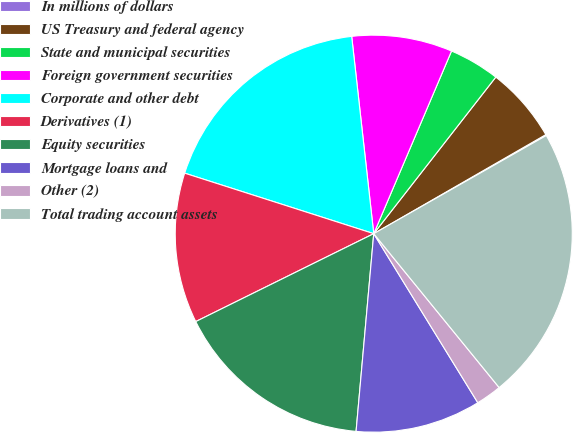<chart> <loc_0><loc_0><loc_500><loc_500><pie_chart><fcel>In millions of dollars<fcel>US Treasury and federal agency<fcel>State and municipal securities<fcel>Foreign government securities<fcel>Corporate and other debt<fcel>Derivatives (1)<fcel>Equity securities<fcel>Mortgage loans and<fcel>Other (2)<fcel>Total trading account assets<nl><fcel>0.08%<fcel>6.15%<fcel>4.13%<fcel>8.18%<fcel>18.3%<fcel>12.23%<fcel>16.28%<fcel>10.2%<fcel>2.1%<fcel>22.35%<nl></chart> 